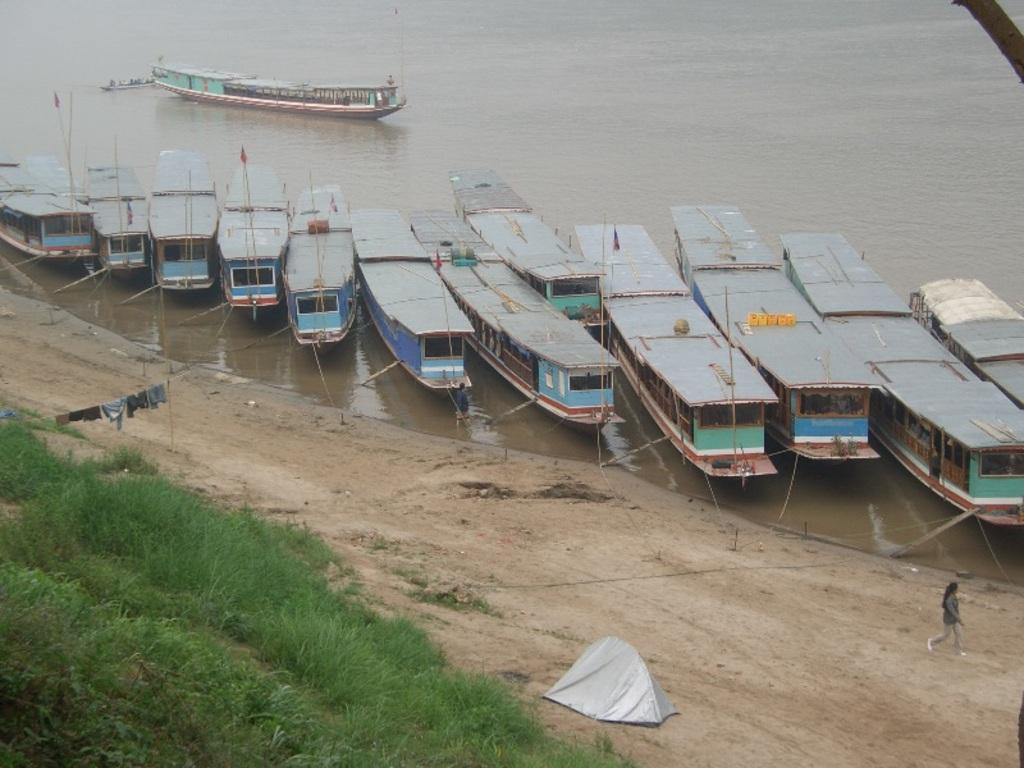What is happening on the water in the image? There are boats on the water in the image. What is the girl in the image doing? The girl is walking in the image. On what surface is the girl walking? The girl is walking on a mud road. What type of vegetation can be seen in the image? Grass is present in the image. What type of sail can be seen on the girl's head in the image? There is no sail present on the girl's head in the image. What type of whistle is the girl using to communicate with the boats? There is no whistle present in the image, and the girl is not communicating with the boats. 